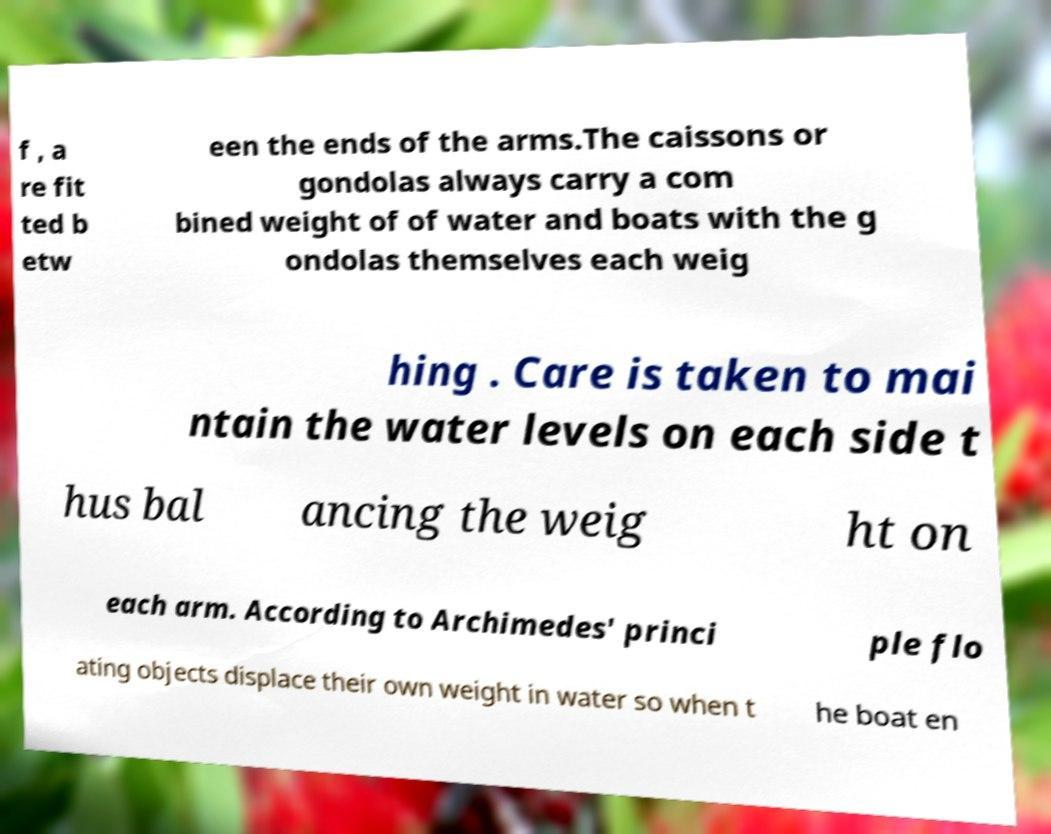Please identify and transcribe the text found in this image. f , a re fit ted b etw een the ends of the arms.The caissons or gondolas always carry a com bined weight of of water and boats with the g ondolas themselves each weig hing . Care is taken to mai ntain the water levels on each side t hus bal ancing the weig ht on each arm. According to Archimedes' princi ple flo ating objects displace their own weight in water so when t he boat en 